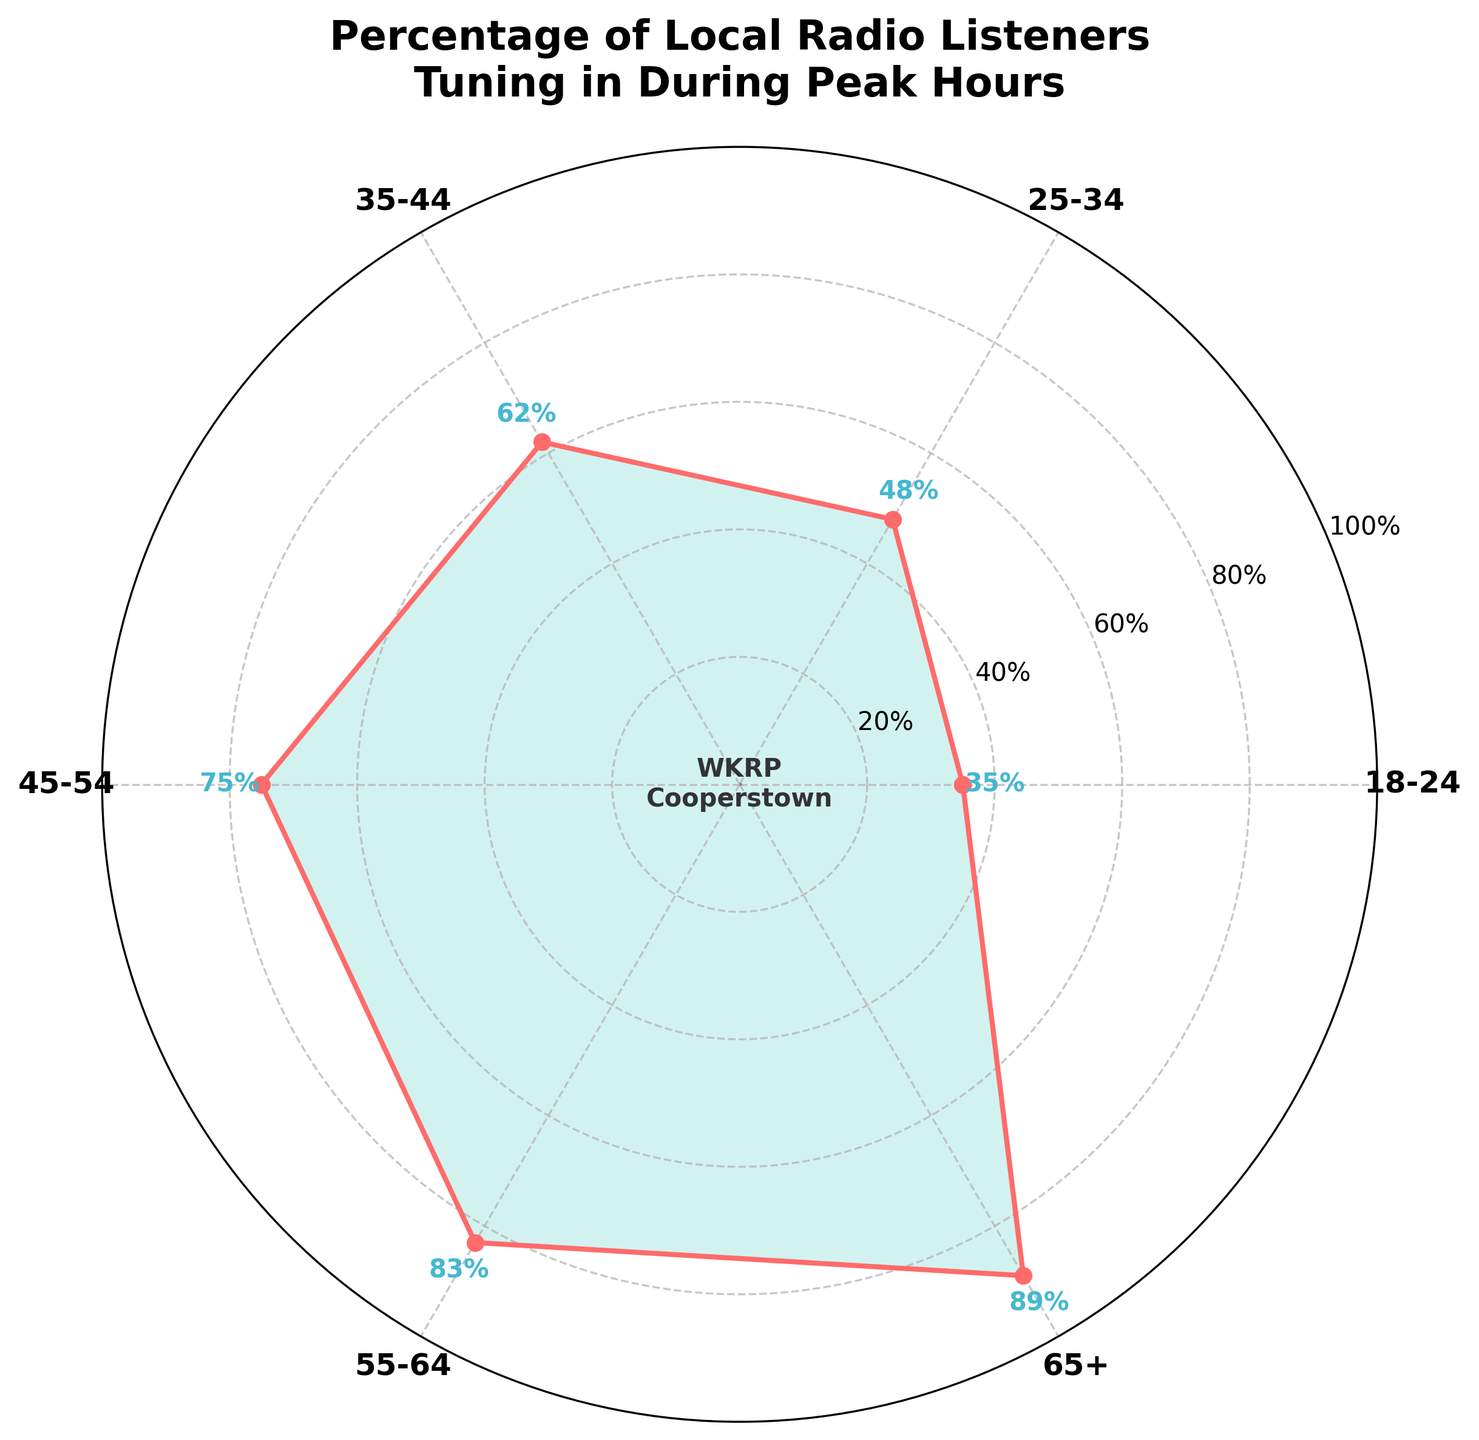What is the title of the figure? The title is usually placed at the top of the figure and is written in a larger, bold font.
Answer: Percentage of Local Radio Listeners Tuning in During Peak Hours What age group has the highest percentage of local radio listeners during peak hours? Look at the labels and percentages on the plot; the age group with the highest percentage will be the one with the largest value.
Answer: 65+ Which age group has the lowest percentage of listeners tuning in during peak hours? Check the percentages for each age group and identify the lowest value.
Answer: 18-24 What is the percentage of listeners tuning in for the 45-54 age group? Locate the 45-54 age group label on the figure and read the corresponding percentage value.
Answer: 75% How many age groups have a percentage of listeners higher than 50%? Reference each age group's percentage and count how many exceed 50%.
Answer: Four What is the average percentage of listeners across all age groups? Add up all the percentages and divide by the number of age groups. The percentages are [35, 48, 62, 75, 83, 89]; (35 + 48 + 62 + 75 + 83 + 89) / 6 = 65.33.
Answer: 65.33% How much higher is the percentage of listeners in the 55-64 age group compared to the 18-24 group? Subtract the percentage of the 18-24 group from the 55-64 group's percentage. Calculation: 83 - 35 = 48.
Answer: 48 Which age groups have percentages that fall between 60% and 80%? Identify the age groups whose percentages are within the range of 60% to 80%.
Answer: 35-44 and 45-54 Is the percentage of listeners in the 25-34 age group greater than 50%? Refer to the percentage for the 25-34 age group; if it is higher than 50%, answer accordingly.
Answer: No What is the combined percentage of listeners for the age groups 18-24 and 25-34? Add the percentages for the 18-24 and 25-34 age groups. Calculation: 35 + 48 = 83.
Answer: 83 